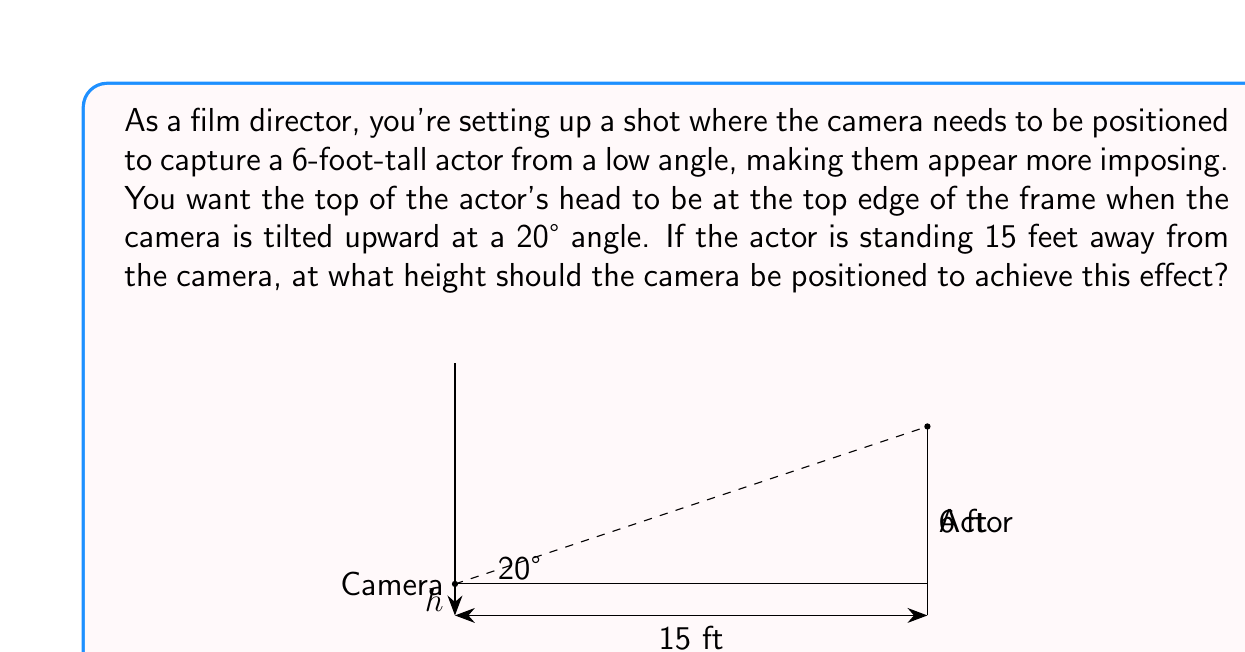Teach me how to tackle this problem. Let's approach this step-by-step using trigonometry:

1) First, let's define our variables:
   $h$ = height of the camera (what we're solving for)
   $\theta$ = angle of camera tilt (20°)
   $d$ = distance to the actor (15 feet)
   $H$ = height of the actor (6 feet)

2) We can see that this forms a right triangle, where:
   - The base of the triangle is the distance to the actor (15 feet)
   - The height of the triangle is the difference between the actor's height and the camera height $(6 - h)$
   - The angle at the camera is 20°

3) We can use the tangent function to relate these:

   $$\tan(20°) = \frac{6 - h}{15}$$

4) Now we can solve for $h$:

   $$15 \cdot \tan(20°) = 6 - h$$
   $$h = 6 - 15 \cdot \tan(20°)$$

5) Let's calculate this:
   $\tan(20°) \approx 0.3640$
   $15 \cdot 0.3640 = 5.46$

   $$h = 6 - 5.46 = 0.54$$

Therefore, the camera should be positioned at a height of approximately 0.54 feet, or about 6.5 inches, above the ground.
Answer: The camera should be positioned at a height of approximately 0.54 feet (or 6.5 inches) above the ground. 